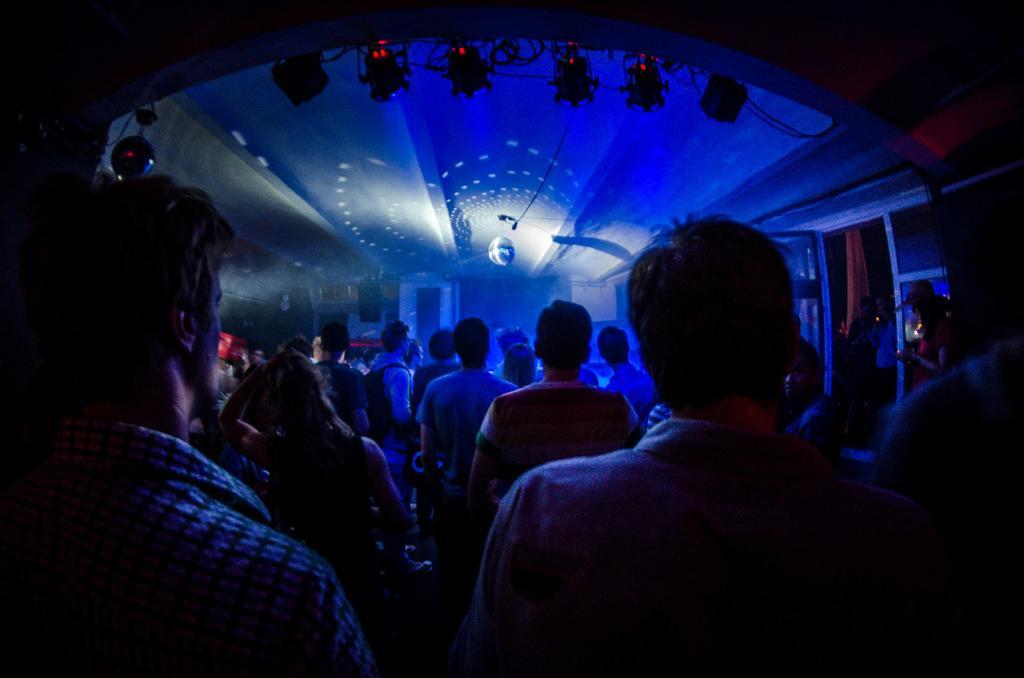Describe this image in one or two sentences. In this image I can see a crowd of people visible and I can see a colorful lighting visible at the top. 